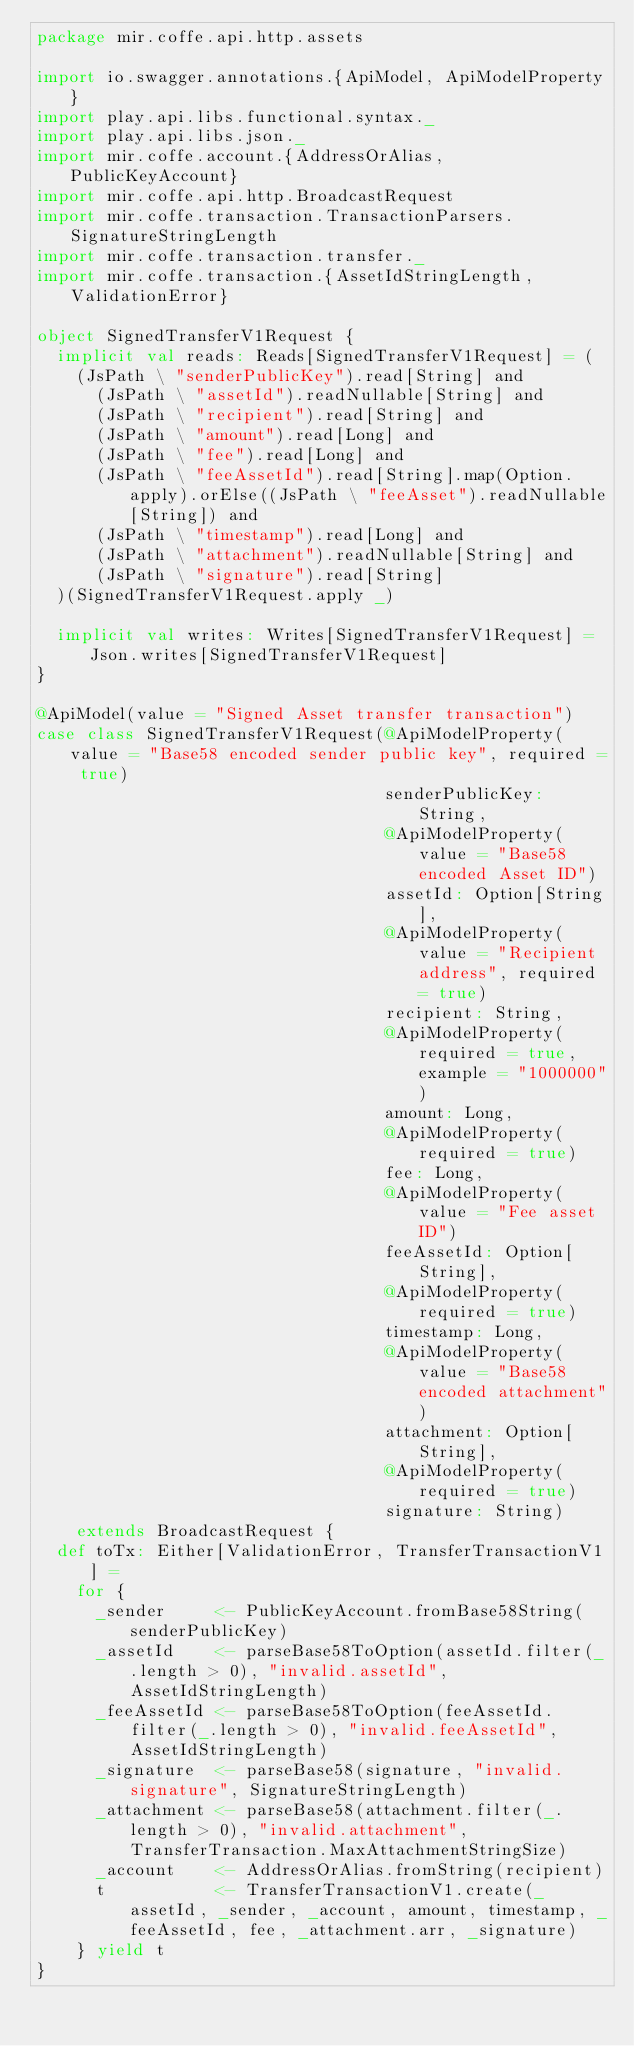<code> <loc_0><loc_0><loc_500><loc_500><_Scala_>package mir.coffe.api.http.assets

import io.swagger.annotations.{ApiModel, ApiModelProperty}
import play.api.libs.functional.syntax._
import play.api.libs.json._
import mir.coffe.account.{AddressOrAlias, PublicKeyAccount}
import mir.coffe.api.http.BroadcastRequest
import mir.coffe.transaction.TransactionParsers.SignatureStringLength
import mir.coffe.transaction.transfer._
import mir.coffe.transaction.{AssetIdStringLength, ValidationError}

object SignedTransferV1Request {
  implicit val reads: Reads[SignedTransferV1Request] = (
    (JsPath \ "senderPublicKey").read[String] and
      (JsPath \ "assetId").readNullable[String] and
      (JsPath \ "recipient").read[String] and
      (JsPath \ "amount").read[Long] and
      (JsPath \ "fee").read[Long] and
      (JsPath \ "feeAssetId").read[String].map(Option.apply).orElse((JsPath \ "feeAsset").readNullable[String]) and
      (JsPath \ "timestamp").read[Long] and
      (JsPath \ "attachment").readNullable[String] and
      (JsPath \ "signature").read[String]
  )(SignedTransferV1Request.apply _)

  implicit val writes: Writes[SignedTransferV1Request] = Json.writes[SignedTransferV1Request]
}

@ApiModel(value = "Signed Asset transfer transaction")
case class SignedTransferV1Request(@ApiModelProperty(value = "Base58 encoded sender public key", required = true)
                                   senderPublicKey: String,
                                   @ApiModelProperty(value = "Base58 encoded Asset ID")
                                   assetId: Option[String],
                                   @ApiModelProperty(value = "Recipient address", required = true)
                                   recipient: String,
                                   @ApiModelProperty(required = true, example = "1000000")
                                   amount: Long,
                                   @ApiModelProperty(required = true)
                                   fee: Long,
                                   @ApiModelProperty(value = "Fee asset ID")
                                   feeAssetId: Option[String],
                                   @ApiModelProperty(required = true)
                                   timestamp: Long,
                                   @ApiModelProperty(value = "Base58 encoded attachment")
                                   attachment: Option[String],
                                   @ApiModelProperty(required = true)
                                   signature: String)
    extends BroadcastRequest {
  def toTx: Either[ValidationError, TransferTransactionV1] =
    for {
      _sender     <- PublicKeyAccount.fromBase58String(senderPublicKey)
      _assetId    <- parseBase58ToOption(assetId.filter(_.length > 0), "invalid.assetId", AssetIdStringLength)
      _feeAssetId <- parseBase58ToOption(feeAssetId.filter(_.length > 0), "invalid.feeAssetId", AssetIdStringLength)
      _signature  <- parseBase58(signature, "invalid.signature", SignatureStringLength)
      _attachment <- parseBase58(attachment.filter(_.length > 0), "invalid.attachment", TransferTransaction.MaxAttachmentStringSize)
      _account    <- AddressOrAlias.fromString(recipient)
      t           <- TransferTransactionV1.create(_assetId, _sender, _account, amount, timestamp, _feeAssetId, fee, _attachment.arr, _signature)
    } yield t
}
</code> 